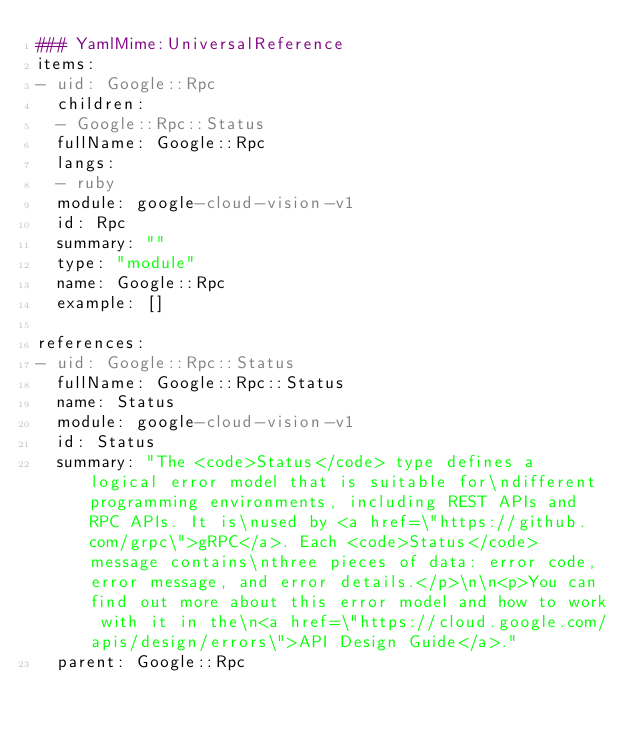Convert code to text. <code><loc_0><loc_0><loc_500><loc_500><_YAML_>### YamlMime:UniversalReference
items:
- uid: Google::Rpc
  children: 
  - Google::Rpc::Status
  fullName: Google::Rpc
  langs:
  - ruby
  module: google-cloud-vision-v1
  id: Rpc
  summary: ""
  type: "module"
  name: Google::Rpc
  example: []

references:
- uid: Google::Rpc::Status
  fullName: Google::Rpc::Status
  name: Status
  module: google-cloud-vision-v1
  id: Status
  summary: "The <code>Status</code> type defines a logical error model that is suitable for\ndifferent programming environments, including REST APIs and RPC APIs. It is\nused by <a href=\"https://github.com/grpc\">gRPC</a>. Each <code>Status</code> message contains\nthree pieces of data: error code, error message, and error details.</p>\n\n<p>You can find out more about this error model and how to work with it in the\n<a href=\"https://cloud.google.com/apis/design/errors\">API Design Guide</a>."
  parent: Google::Rpc</code> 